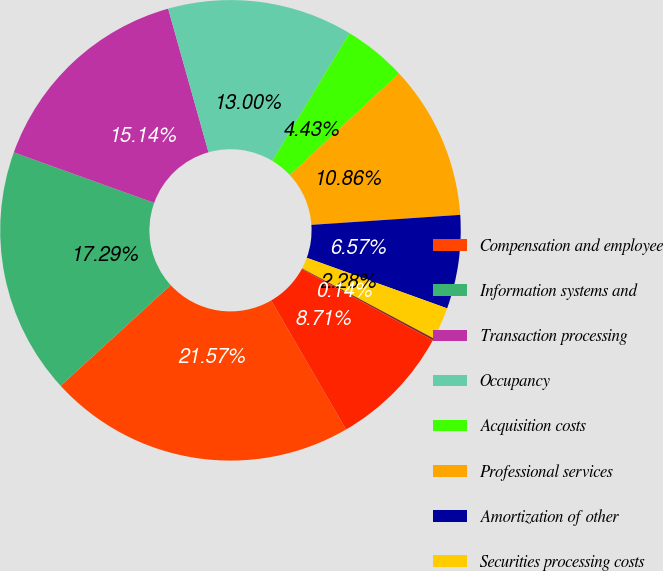<chart> <loc_0><loc_0><loc_500><loc_500><pie_chart><fcel>Compensation and employee<fcel>Information systems and<fcel>Transaction processing<fcel>Occupancy<fcel>Acquisition costs<fcel>Professional services<fcel>Amortization of other<fcel>Securities processing costs<fcel>Regulator fees and assessments<fcel>Other<nl><fcel>21.57%<fcel>17.29%<fcel>15.14%<fcel>13.0%<fcel>4.43%<fcel>10.86%<fcel>6.57%<fcel>2.28%<fcel>0.14%<fcel>8.71%<nl></chart> 